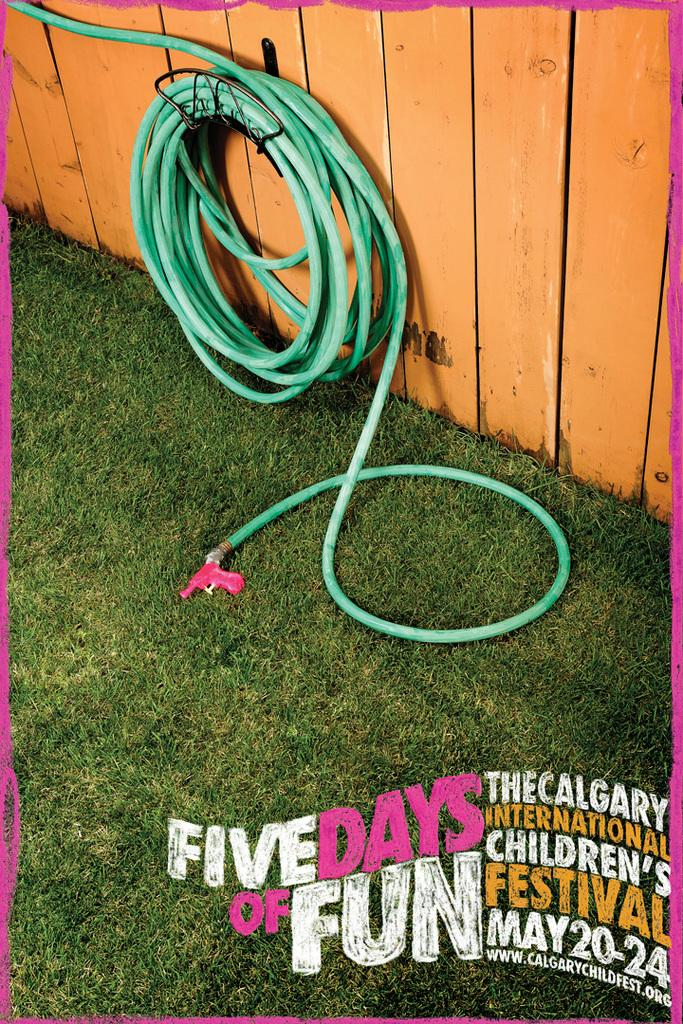What type of vegetation is present on the ground in the image? There is grass on the ground in the image. What can be seen in the background of the image? There is a pipe and a wooden wall in the background of the image. What is written or depicted on the wooden wall? There is text visible on the wooden wall. How many wrens are perched on the pipe in the image? There are no wrens present in the image; the pipe is the only object mentioned in the background. 